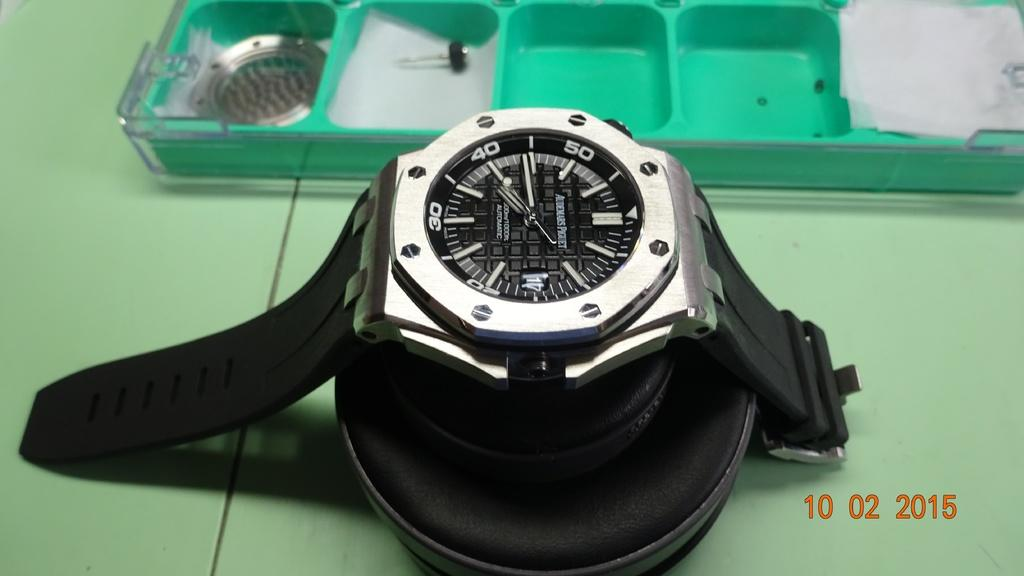<image>
Create a compact narrative representing the image presented. A photo of a black watch is dated "10 02 2015." 